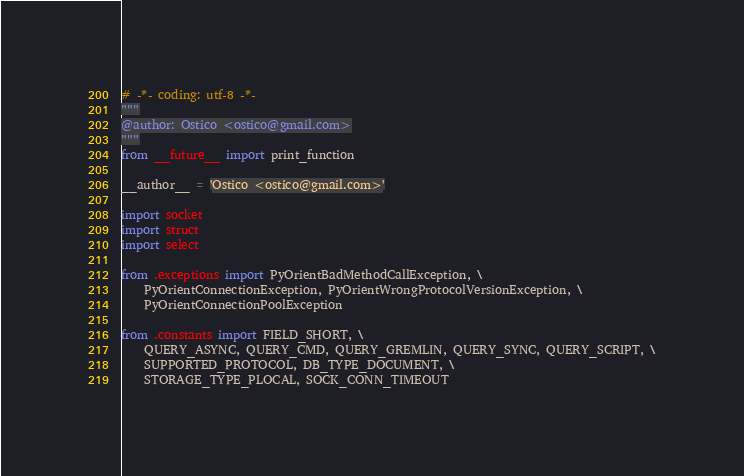<code> <loc_0><loc_0><loc_500><loc_500><_Python_># -*- coding: utf-8 -*-
"""
@author: Ostico <ostico@gmail.com>
"""
from __future__ import print_function

__author__ = 'Ostico <ostico@gmail.com>'

import socket
import struct
import select

from .exceptions import PyOrientBadMethodCallException, \
    PyOrientConnectionException, PyOrientWrongProtocolVersionException, \
    PyOrientConnectionPoolException

from .constants import FIELD_SHORT, \
    QUERY_ASYNC, QUERY_CMD, QUERY_GREMLIN, QUERY_SYNC, QUERY_SCRIPT, \
    SUPPORTED_PROTOCOL, DB_TYPE_DOCUMENT, \
    STORAGE_TYPE_PLOCAL, SOCK_CONN_TIMEOUT
</code> 